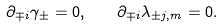<formula> <loc_0><loc_0><loc_500><loc_500>\partial _ { \mp i } \gamma _ { \pm } = 0 , \quad \partial _ { \mp i } \lambda _ { \pm j , m } = 0 .</formula> 